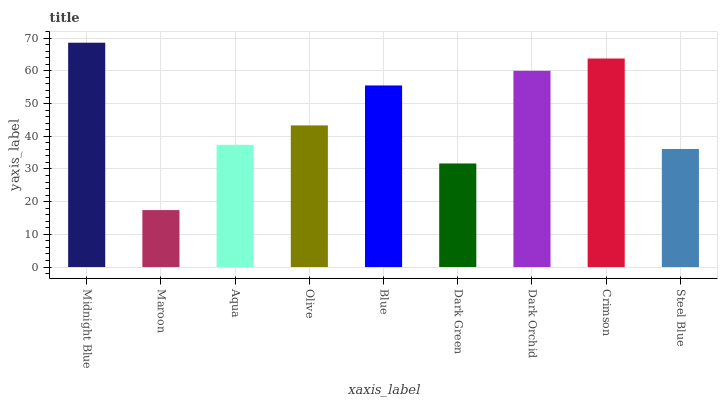Is Aqua the minimum?
Answer yes or no. No. Is Aqua the maximum?
Answer yes or no. No. Is Aqua greater than Maroon?
Answer yes or no. Yes. Is Maroon less than Aqua?
Answer yes or no. Yes. Is Maroon greater than Aqua?
Answer yes or no. No. Is Aqua less than Maroon?
Answer yes or no. No. Is Olive the high median?
Answer yes or no. Yes. Is Olive the low median?
Answer yes or no. Yes. Is Dark Green the high median?
Answer yes or no. No. Is Midnight Blue the low median?
Answer yes or no. No. 